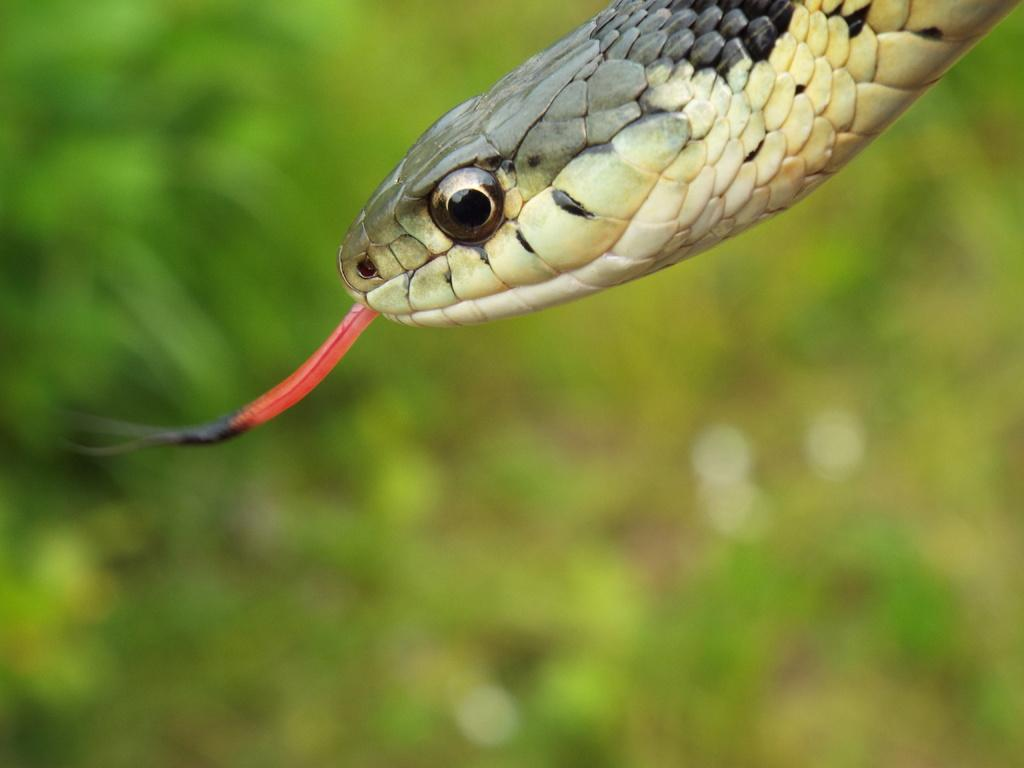What animal is present in the image? There is a snake in the image. Can you describe the background of the image? The background of the image is blurred. What type of bath does the governor take in the image? There is no reference to a bath or a governor in the image, so it is not possible to answer that question. 